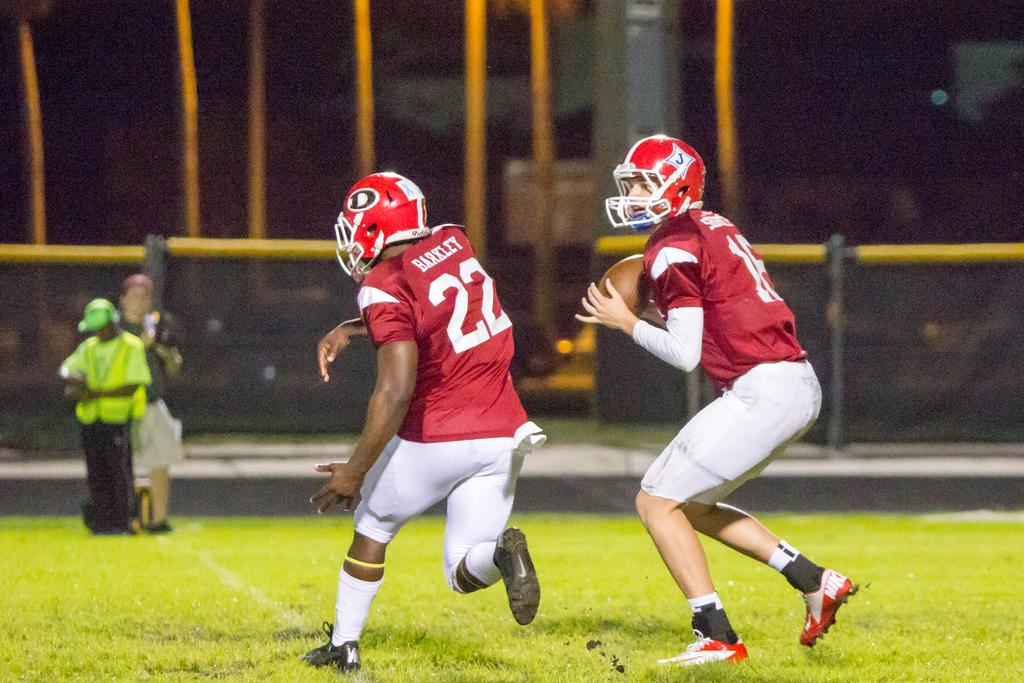What activity are the two persons in the image engaged in? The two persons in the image are playing a sprint football game. What type of surface is visible at the bottom of the image? There is grass at the bottom of the image. What protective gear are the players wearing? The players are wearing helmets. Can you describe the people in the background of the image? There are two persons standing in the background of the image. What type of joke is being told by the players during the game? There is no indication in the image that the players are telling a joke or making any statements. --- Facts: 1. There is a person holding a guitar in the image. 2. The person is sitting on a chair. 3. There is a microphone stand in front of the person. 4. The background of the image is dark. Absurd Topics: dance, ocean, sculpture Conversation: What is the person in the image holding? The person in the image is holding a guitar. What is the person's position in the image? The person is sitting on a chair. What equipment is visible in front of the person? There is a microphone stand in front of the person. How would you describe the lighting in the image? The background of the image is dark. Reasoning: Let's think step by step in order to produce the conversation. We start by identifying the main subject in the image, which is the person holding a guitar. Then, we describe the person's position, which is sitting on a chair. Next, we mention the equipment visible in front of the person, which is a microphone stand. Finally, we acknowledge the lighting in the image, which is dark. Absurd Question/Answer: Can you see any sculptures in the background of the image? There is no sculpture present in the image; the background is dark. 